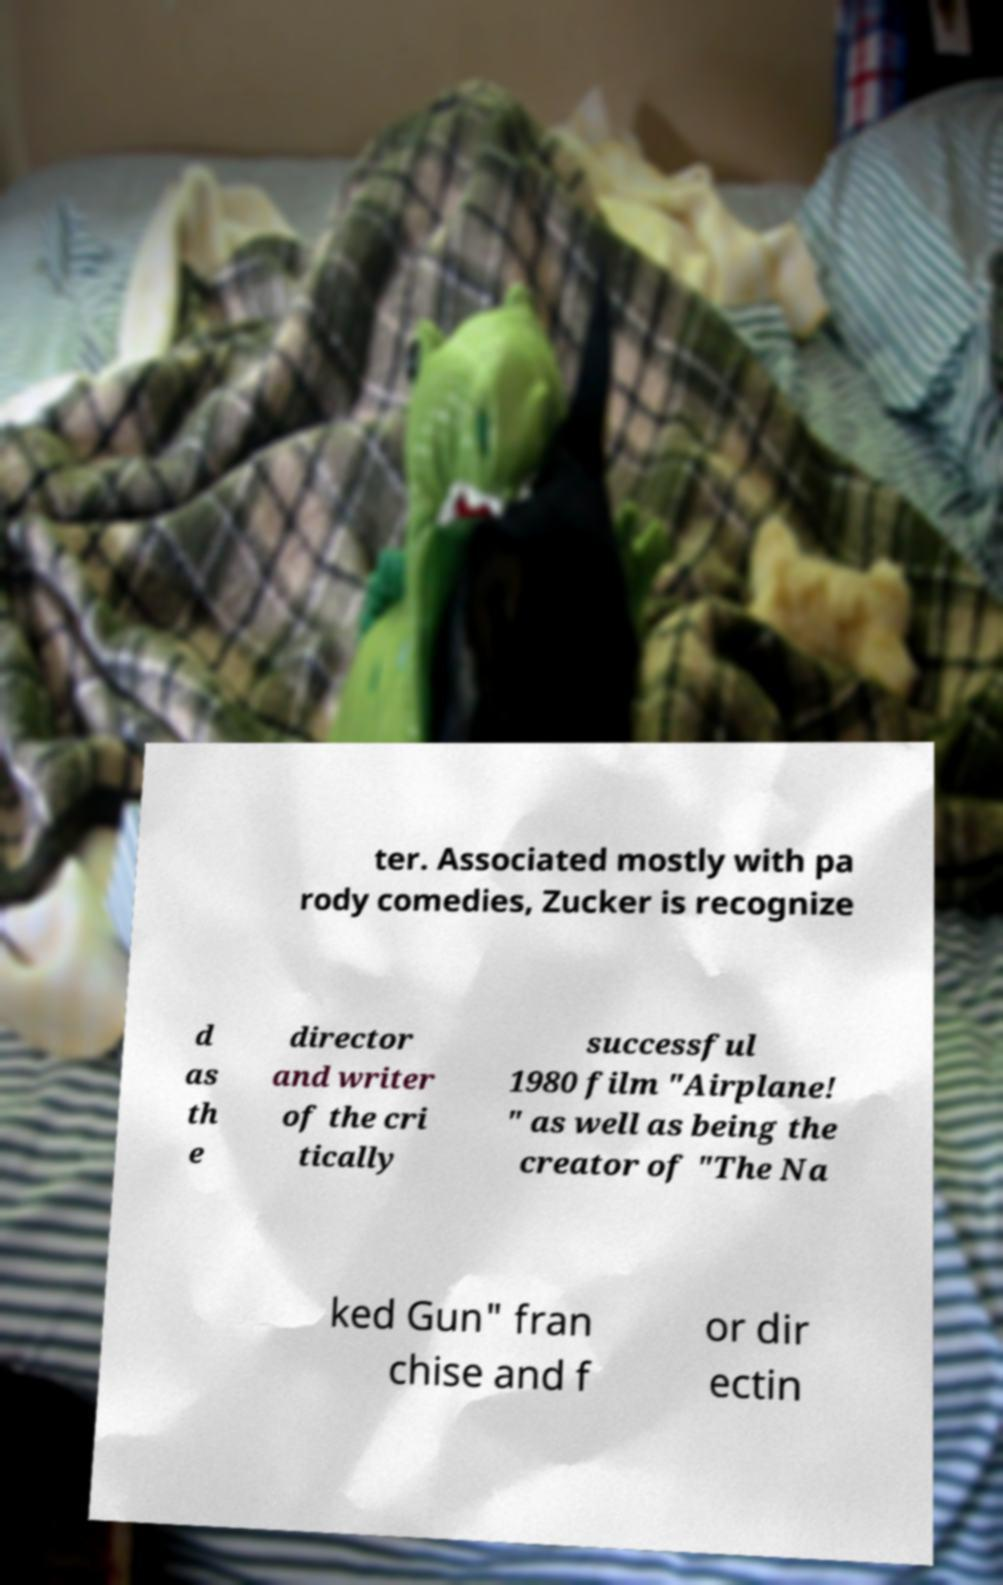Could you assist in decoding the text presented in this image and type it out clearly? ter. Associated mostly with pa rody comedies, Zucker is recognize d as th e director and writer of the cri tically successful 1980 film "Airplane! " as well as being the creator of "The Na ked Gun" fran chise and f or dir ectin 